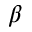<formula> <loc_0><loc_0><loc_500><loc_500>\beta</formula> 